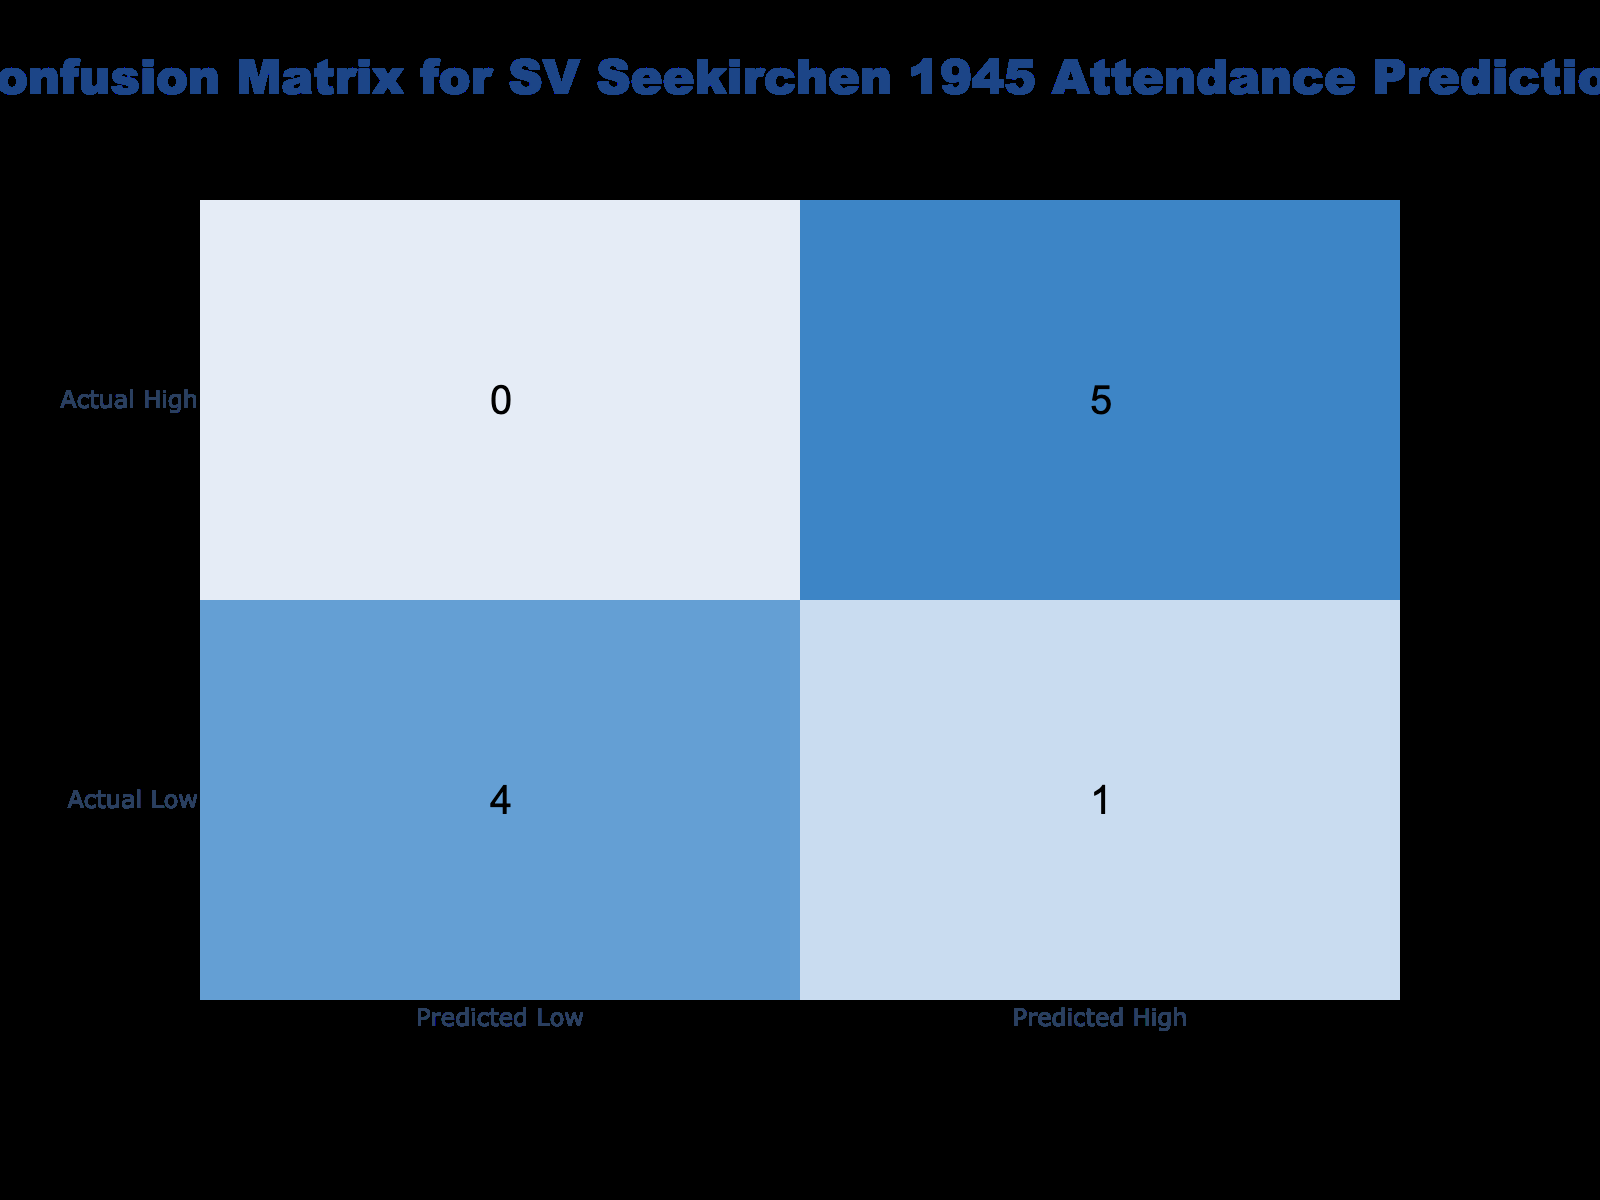What is the total number of correct predictions made for low attendance? Looking at the confusion matrix, we see that the actual low attendance recorded two correct predictions (Predicted Low for Actual Low). Therefore, there are two correct predictions for low attendance.
Answer: 2 How many times was high attendance predicted incorrectly? In the table, the predicted attendance for high attendance was incorrect twice (Predicted Low for Actual High). Therefore, the total number of incorrect predictions for high attendance is two.
Answer: 2 What is the proportion of correct predictions to the total predictions made? There are a total of ten predictions made (sum of both correct and incorrect predictions). The correct predictions added up to five. The proportion is 5 correct predictions out of 10 total predictions, which is 5/10 = 0.5 or 50%.
Answer: 50% How many predictions were made for low attendance? The confusion matrix shows that there were four actual low attendance occurrences (2 correct and 2 incorrect), so the number of predictions made for low attendance is four.
Answer: 4 Is it true that all actual high attendance situations were correctly predicted? Looking at the table, we see that there were four actual high attendance records and all of them were accurately captured in predictions. Therefore, this statement is true.
Answer: Yes What was the total number of high attendances predicted? The confusion matrix indicates that high attendance was predicted six times (four correct and two incorrect). Thus, to find the total predictions made for high attendance, we add these values together.
Answer: 6 If we consider only the correct predictions for low attendance, what percentage do they represent out of all low attendance forecasts? There were four predictions made for low attendance (2 correct and 2 incorrect). The correct predictions made for low attendance total two. To find the percentage: (2 correct predictions / 4 total predictions) * 100 = 50%.
Answer: 50% How many total incorrect predictions were made overall? By summing up the incorrect predictions in both low and high attendance categories, we find there were five incorrect predictions (2 for low, 3 for high). Therefore, the total number of incorrect predictions is five.
Answer: 5 What is the difference between the number of correct predictions for low and high attendance? The number of correct predictions for low attendance is two, and for high attendance, it is three. Taking the difference yields 3 minus 2, which equals 1.
Answer: 1 